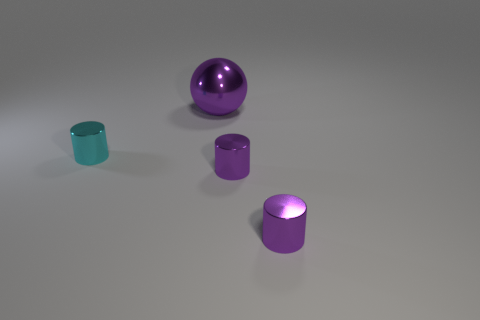Subtract all cyan cylinders. How many cylinders are left? 2 Subtract all cyan cylinders. How many cylinders are left? 2 Add 4 small shiny objects. How many objects exist? 8 Subtract all cylinders. How many objects are left? 1 Subtract 1 cylinders. How many cylinders are left? 2 Add 1 red metallic blocks. How many red metallic blocks exist? 1 Subtract 0 green cylinders. How many objects are left? 4 Subtract all brown cylinders. Subtract all gray balls. How many cylinders are left? 3 Subtract all yellow cylinders. How many blue spheres are left? 0 Subtract all big red matte things. Subtract all small purple shiny cylinders. How many objects are left? 2 